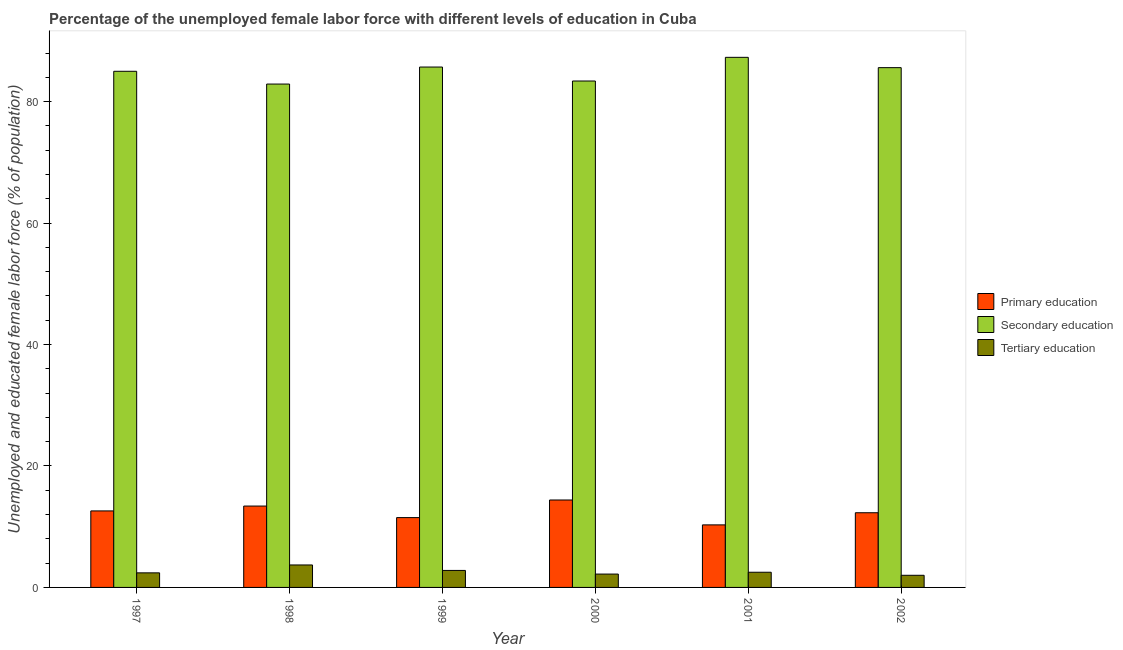How many different coloured bars are there?
Your answer should be very brief. 3. Are the number of bars per tick equal to the number of legend labels?
Offer a very short reply. Yes. Are the number of bars on each tick of the X-axis equal?
Your answer should be compact. Yes. What is the label of the 1st group of bars from the left?
Offer a terse response. 1997. What is the percentage of female labor force who received secondary education in 2002?
Make the answer very short. 85.6. Across all years, what is the maximum percentage of female labor force who received secondary education?
Provide a short and direct response. 87.3. Across all years, what is the minimum percentage of female labor force who received secondary education?
Provide a succinct answer. 82.9. What is the total percentage of female labor force who received secondary education in the graph?
Offer a very short reply. 509.9. What is the difference between the percentage of female labor force who received secondary education in 2000 and that in 2001?
Make the answer very short. -3.9. What is the difference between the percentage of female labor force who received primary education in 1999 and the percentage of female labor force who received tertiary education in 2000?
Provide a short and direct response. -2.9. What is the average percentage of female labor force who received tertiary education per year?
Keep it short and to the point. 2.6. What is the ratio of the percentage of female labor force who received secondary education in 1997 to that in 1999?
Offer a terse response. 0.99. Is the percentage of female labor force who received secondary education in 1999 less than that in 2000?
Make the answer very short. No. What is the difference between the highest and the second highest percentage of female labor force who received tertiary education?
Your answer should be compact. 0.9. What is the difference between the highest and the lowest percentage of female labor force who received tertiary education?
Your response must be concise. 1.7. In how many years, is the percentage of female labor force who received tertiary education greater than the average percentage of female labor force who received tertiary education taken over all years?
Offer a very short reply. 2. Is the sum of the percentage of female labor force who received tertiary education in 1999 and 2002 greater than the maximum percentage of female labor force who received primary education across all years?
Provide a short and direct response. Yes. What does the 3rd bar from the right in 2000 represents?
Provide a short and direct response. Primary education. What is the difference between two consecutive major ticks on the Y-axis?
Make the answer very short. 20. Are the values on the major ticks of Y-axis written in scientific E-notation?
Your answer should be compact. No. Does the graph contain any zero values?
Keep it short and to the point. No. Does the graph contain grids?
Keep it short and to the point. No. Where does the legend appear in the graph?
Ensure brevity in your answer.  Center right. How are the legend labels stacked?
Your answer should be compact. Vertical. What is the title of the graph?
Your response must be concise. Percentage of the unemployed female labor force with different levels of education in Cuba. What is the label or title of the X-axis?
Offer a terse response. Year. What is the label or title of the Y-axis?
Make the answer very short. Unemployed and educated female labor force (% of population). What is the Unemployed and educated female labor force (% of population) in Primary education in 1997?
Give a very brief answer. 12.6. What is the Unemployed and educated female labor force (% of population) of Tertiary education in 1997?
Provide a succinct answer. 2.4. What is the Unemployed and educated female labor force (% of population) in Primary education in 1998?
Your answer should be compact. 13.4. What is the Unemployed and educated female labor force (% of population) of Secondary education in 1998?
Offer a terse response. 82.9. What is the Unemployed and educated female labor force (% of population) in Tertiary education in 1998?
Offer a terse response. 3.7. What is the Unemployed and educated female labor force (% of population) of Primary education in 1999?
Provide a short and direct response. 11.5. What is the Unemployed and educated female labor force (% of population) in Secondary education in 1999?
Ensure brevity in your answer.  85.7. What is the Unemployed and educated female labor force (% of population) of Tertiary education in 1999?
Offer a terse response. 2.8. What is the Unemployed and educated female labor force (% of population) of Primary education in 2000?
Keep it short and to the point. 14.4. What is the Unemployed and educated female labor force (% of population) in Secondary education in 2000?
Offer a very short reply. 83.4. What is the Unemployed and educated female labor force (% of population) of Tertiary education in 2000?
Offer a terse response. 2.2. What is the Unemployed and educated female labor force (% of population) in Primary education in 2001?
Give a very brief answer. 10.3. What is the Unemployed and educated female labor force (% of population) of Secondary education in 2001?
Provide a succinct answer. 87.3. What is the Unemployed and educated female labor force (% of population) of Tertiary education in 2001?
Your answer should be compact. 2.5. What is the Unemployed and educated female labor force (% of population) of Primary education in 2002?
Your response must be concise. 12.3. What is the Unemployed and educated female labor force (% of population) in Secondary education in 2002?
Give a very brief answer. 85.6. Across all years, what is the maximum Unemployed and educated female labor force (% of population) of Primary education?
Offer a terse response. 14.4. Across all years, what is the maximum Unemployed and educated female labor force (% of population) in Secondary education?
Offer a terse response. 87.3. Across all years, what is the maximum Unemployed and educated female labor force (% of population) in Tertiary education?
Your answer should be compact. 3.7. Across all years, what is the minimum Unemployed and educated female labor force (% of population) in Primary education?
Your response must be concise. 10.3. Across all years, what is the minimum Unemployed and educated female labor force (% of population) in Secondary education?
Provide a succinct answer. 82.9. What is the total Unemployed and educated female labor force (% of population) in Primary education in the graph?
Your answer should be compact. 74.5. What is the total Unemployed and educated female labor force (% of population) of Secondary education in the graph?
Provide a short and direct response. 509.9. What is the difference between the Unemployed and educated female labor force (% of population) of Primary education in 1997 and that in 2000?
Ensure brevity in your answer.  -1.8. What is the difference between the Unemployed and educated female labor force (% of population) of Tertiary education in 1997 and that in 2002?
Ensure brevity in your answer.  0.4. What is the difference between the Unemployed and educated female labor force (% of population) of Primary education in 1998 and that in 1999?
Offer a terse response. 1.9. What is the difference between the Unemployed and educated female labor force (% of population) of Secondary education in 1998 and that in 1999?
Your answer should be compact. -2.8. What is the difference between the Unemployed and educated female labor force (% of population) in Tertiary education in 1998 and that in 1999?
Give a very brief answer. 0.9. What is the difference between the Unemployed and educated female labor force (% of population) in Secondary education in 1998 and that in 2000?
Provide a succinct answer. -0.5. What is the difference between the Unemployed and educated female labor force (% of population) in Tertiary education in 1998 and that in 2000?
Your answer should be compact. 1.5. What is the difference between the Unemployed and educated female labor force (% of population) of Secondary education in 1998 and that in 2001?
Your answer should be compact. -4.4. What is the difference between the Unemployed and educated female labor force (% of population) in Tertiary education in 1998 and that in 2001?
Ensure brevity in your answer.  1.2. What is the difference between the Unemployed and educated female labor force (% of population) of Primary education in 1998 and that in 2002?
Your answer should be very brief. 1.1. What is the difference between the Unemployed and educated female labor force (% of population) of Secondary education in 1998 and that in 2002?
Make the answer very short. -2.7. What is the difference between the Unemployed and educated female labor force (% of population) of Primary education in 1999 and that in 2000?
Your answer should be very brief. -2.9. What is the difference between the Unemployed and educated female labor force (% of population) of Tertiary education in 1999 and that in 2000?
Provide a short and direct response. 0.6. What is the difference between the Unemployed and educated female labor force (% of population) in Primary education in 1999 and that in 2001?
Keep it short and to the point. 1.2. What is the difference between the Unemployed and educated female labor force (% of population) of Secondary education in 1999 and that in 2001?
Your answer should be very brief. -1.6. What is the difference between the Unemployed and educated female labor force (% of population) of Tertiary education in 1999 and that in 2001?
Your response must be concise. 0.3. What is the difference between the Unemployed and educated female labor force (% of population) of Primary education in 2000 and that in 2001?
Make the answer very short. 4.1. What is the difference between the Unemployed and educated female labor force (% of population) in Primary education in 2000 and that in 2002?
Offer a terse response. 2.1. What is the difference between the Unemployed and educated female labor force (% of population) in Secondary education in 2000 and that in 2002?
Provide a short and direct response. -2.2. What is the difference between the Unemployed and educated female labor force (% of population) of Secondary education in 2001 and that in 2002?
Your answer should be very brief. 1.7. What is the difference between the Unemployed and educated female labor force (% of population) in Primary education in 1997 and the Unemployed and educated female labor force (% of population) in Secondary education in 1998?
Ensure brevity in your answer.  -70.3. What is the difference between the Unemployed and educated female labor force (% of population) in Secondary education in 1997 and the Unemployed and educated female labor force (% of population) in Tertiary education in 1998?
Offer a very short reply. 81.3. What is the difference between the Unemployed and educated female labor force (% of population) in Primary education in 1997 and the Unemployed and educated female labor force (% of population) in Secondary education in 1999?
Provide a succinct answer. -73.1. What is the difference between the Unemployed and educated female labor force (% of population) in Primary education in 1997 and the Unemployed and educated female labor force (% of population) in Tertiary education in 1999?
Keep it short and to the point. 9.8. What is the difference between the Unemployed and educated female labor force (% of population) of Secondary education in 1997 and the Unemployed and educated female labor force (% of population) of Tertiary education in 1999?
Make the answer very short. 82.2. What is the difference between the Unemployed and educated female labor force (% of population) of Primary education in 1997 and the Unemployed and educated female labor force (% of population) of Secondary education in 2000?
Keep it short and to the point. -70.8. What is the difference between the Unemployed and educated female labor force (% of population) in Primary education in 1997 and the Unemployed and educated female labor force (% of population) in Tertiary education in 2000?
Offer a very short reply. 10.4. What is the difference between the Unemployed and educated female labor force (% of population) of Secondary education in 1997 and the Unemployed and educated female labor force (% of population) of Tertiary education in 2000?
Keep it short and to the point. 82.8. What is the difference between the Unemployed and educated female labor force (% of population) of Primary education in 1997 and the Unemployed and educated female labor force (% of population) of Secondary education in 2001?
Your answer should be very brief. -74.7. What is the difference between the Unemployed and educated female labor force (% of population) in Secondary education in 1997 and the Unemployed and educated female labor force (% of population) in Tertiary education in 2001?
Ensure brevity in your answer.  82.5. What is the difference between the Unemployed and educated female labor force (% of population) of Primary education in 1997 and the Unemployed and educated female labor force (% of population) of Secondary education in 2002?
Your answer should be very brief. -73. What is the difference between the Unemployed and educated female labor force (% of population) of Secondary education in 1997 and the Unemployed and educated female labor force (% of population) of Tertiary education in 2002?
Provide a succinct answer. 83. What is the difference between the Unemployed and educated female labor force (% of population) in Primary education in 1998 and the Unemployed and educated female labor force (% of population) in Secondary education in 1999?
Give a very brief answer. -72.3. What is the difference between the Unemployed and educated female labor force (% of population) in Primary education in 1998 and the Unemployed and educated female labor force (% of population) in Tertiary education in 1999?
Make the answer very short. 10.6. What is the difference between the Unemployed and educated female labor force (% of population) in Secondary education in 1998 and the Unemployed and educated female labor force (% of population) in Tertiary education in 1999?
Offer a terse response. 80.1. What is the difference between the Unemployed and educated female labor force (% of population) in Primary education in 1998 and the Unemployed and educated female labor force (% of population) in Secondary education in 2000?
Keep it short and to the point. -70. What is the difference between the Unemployed and educated female labor force (% of population) in Secondary education in 1998 and the Unemployed and educated female labor force (% of population) in Tertiary education in 2000?
Give a very brief answer. 80.7. What is the difference between the Unemployed and educated female labor force (% of population) in Primary education in 1998 and the Unemployed and educated female labor force (% of population) in Secondary education in 2001?
Provide a succinct answer. -73.9. What is the difference between the Unemployed and educated female labor force (% of population) in Primary education in 1998 and the Unemployed and educated female labor force (% of population) in Tertiary education in 2001?
Your response must be concise. 10.9. What is the difference between the Unemployed and educated female labor force (% of population) of Secondary education in 1998 and the Unemployed and educated female labor force (% of population) of Tertiary education in 2001?
Give a very brief answer. 80.4. What is the difference between the Unemployed and educated female labor force (% of population) of Primary education in 1998 and the Unemployed and educated female labor force (% of population) of Secondary education in 2002?
Make the answer very short. -72.2. What is the difference between the Unemployed and educated female labor force (% of population) of Secondary education in 1998 and the Unemployed and educated female labor force (% of population) of Tertiary education in 2002?
Your answer should be compact. 80.9. What is the difference between the Unemployed and educated female labor force (% of population) of Primary education in 1999 and the Unemployed and educated female labor force (% of population) of Secondary education in 2000?
Provide a succinct answer. -71.9. What is the difference between the Unemployed and educated female labor force (% of population) in Secondary education in 1999 and the Unemployed and educated female labor force (% of population) in Tertiary education in 2000?
Ensure brevity in your answer.  83.5. What is the difference between the Unemployed and educated female labor force (% of population) of Primary education in 1999 and the Unemployed and educated female labor force (% of population) of Secondary education in 2001?
Make the answer very short. -75.8. What is the difference between the Unemployed and educated female labor force (% of population) in Secondary education in 1999 and the Unemployed and educated female labor force (% of population) in Tertiary education in 2001?
Provide a short and direct response. 83.2. What is the difference between the Unemployed and educated female labor force (% of population) in Primary education in 1999 and the Unemployed and educated female labor force (% of population) in Secondary education in 2002?
Give a very brief answer. -74.1. What is the difference between the Unemployed and educated female labor force (% of population) in Secondary education in 1999 and the Unemployed and educated female labor force (% of population) in Tertiary education in 2002?
Offer a terse response. 83.7. What is the difference between the Unemployed and educated female labor force (% of population) in Primary education in 2000 and the Unemployed and educated female labor force (% of population) in Secondary education in 2001?
Give a very brief answer. -72.9. What is the difference between the Unemployed and educated female labor force (% of population) of Primary education in 2000 and the Unemployed and educated female labor force (% of population) of Tertiary education in 2001?
Offer a terse response. 11.9. What is the difference between the Unemployed and educated female labor force (% of population) of Secondary education in 2000 and the Unemployed and educated female labor force (% of population) of Tertiary education in 2001?
Keep it short and to the point. 80.9. What is the difference between the Unemployed and educated female labor force (% of population) in Primary education in 2000 and the Unemployed and educated female labor force (% of population) in Secondary education in 2002?
Offer a very short reply. -71.2. What is the difference between the Unemployed and educated female labor force (% of population) of Secondary education in 2000 and the Unemployed and educated female labor force (% of population) of Tertiary education in 2002?
Your answer should be compact. 81.4. What is the difference between the Unemployed and educated female labor force (% of population) in Primary education in 2001 and the Unemployed and educated female labor force (% of population) in Secondary education in 2002?
Provide a succinct answer. -75.3. What is the difference between the Unemployed and educated female labor force (% of population) in Secondary education in 2001 and the Unemployed and educated female labor force (% of population) in Tertiary education in 2002?
Provide a succinct answer. 85.3. What is the average Unemployed and educated female labor force (% of population) of Primary education per year?
Provide a short and direct response. 12.42. What is the average Unemployed and educated female labor force (% of population) in Secondary education per year?
Offer a very short reply. 84.98. What is the average Unemployed and educated female labor force (% of population) in Tertiary education per year?
Provide a short and direct response. 2.6. In the year 1997, what is the difference between the Unemployed and educated female labor force (% of population) of Primary education and Unemployed and educated female labor force (% of population) of Secondary education?
Your answer should be very brief. -72.4. In the year 1997, what is the difference between the Unemployed and educated female labor force (% of population) in Secondary education and Unemployed and educated female labor force (% of population) in Tertiary education?
Provide a short and direct response. 82.6. In the year 1998, what is the difference between the Unemployed and educated female labor force (% of population) of Primary education and Unemployed and educated female labor force (% of population) of Secondary education?
Your answer should be very brief. -69.5. In the year 1998, what is the difference between the Unemployed and educated female labor force (% of population) in Secondary education and Unemployed and educated female labor force (% of population) in Tertiary education?
Provide a short and direct response. 79.2. In the year 1999, what is the difference between the Unemployed and educated female labor force (% of population) of Primary education and Unemployed and educated female labor force (% of population) of Secondary education?
Keep it short and to the point. -74.2. In the year 1999, what is the difference between the Unemployed and educated female labor force (% of population) in Secondary education and Unemployed and educated female labor force (% of population) in Tertiary education?
Make the answer very short. 82.9. In the year 2000, what is the difference between the Unemployed and educated female labor force (% of population) in Primary education and Unemployed and educated female labor force (% of population) in Secondary education?
Provide a short and direct response. -69. In the year 2000, what is the difference between the Unemployed and educated female labor force (% of population) of Primary education and Unemployed and educated female labor force (% of population) of Tertiary education?
Provide a succinct answer. 12.2. In the year 2000, what is the difference between the Unemployed and educated female labor force (% of population) in Secondary education and Unemployed and educated female labor force (% of population) in Tertiary education?
Your response must be concise. 81.2. In the year 2001, what is the difference between the Unemployed and educated female labor force (% of population) of Primary education and Unemployed and educated female labor force (% of population) of Secondary education?
Give a very brief answer. -77. In the year 2001, what is the difference between the Unemployed and educated female labor force (% of population) in Secondary education and Unemployed and educated female labor force (% of population) in Tertiary education?
Ensure brevity in your answer.  84.8. In the year 2002, what is the difference between the Unemployed and educated female labor force (% of population) of Primary education and Unemployed and educated female labor force (% of population) of Secondary education?
Ensure brevity in your answer.  -73.3. In the year 2002, what is the difference between the Unemployed and educated female labor force (% of population) of Primary education and Unemployed and educated female labor force (% of population) of Tertiary education?
Your answer should be very brief. 10.3. In the year 2002, what is the difference between the Unemployed and educated female labor force (% of population) in Secondary education and Unemployed and educated female labor force (% of population) in Tertiary education?
Give a very brief answer. 83.6. What is the ratio of the Unemployed and educated female labor force (% of population) of Primary education in 1997 to that in 1998?
Give a very brief answer. 0.94. What is the ratio of the Unemployed and educated female labor force (% of population) in Secondary education in 1997 to that in 1998?
Your answer should be very brief. 1.03. What is the ratio of the Unemployed and educated female labor force (% of population) in Tertiary education in 1997 to that in 1998?
Your response must be concise. 0.65. What is the ratio of the Unemployed and educated female labor force (% of population) in Primary education in 1997 to that in 1999?
Make the answer very short. 1.1. What is the ratio of the Unemployed and educated female labor force (% of population) of Secondary education in 1997 to that in 1999?
Provide a short and direct response. 0.99. What is the ratio of the Unemployed and educated female labor force (% of population) of Tertiary education in 1997 to that in 1999?
Make the answer very short. 0.86. What is the ratio of the Unemployed and educated female labor force (% of population) of Secondary education in 1997 to that in 2000?
Provide a succinct answer. 1.02. What is the ratio of the Unemployed and educated female labor force (% of population) in Primary education in 1997 to that in 2001?
Offer a very short reply. 1.22. What is the ratio of the Unemployed and educated female labor force (% of population) of Secondary education in 1997 to that in 2001?
Provide a short and direct response. 0.97. What is the ratio of the Unemployed and educated female labor force (% of population) of Tertiary education in 1997 to that in 2001?
Your answer should be compact. 0.96. What is the ratio of the Unemployed and educated female labor force (% of population) in Primary education in 1997 to that in 2002?
Offer a terse response. 1.02. What is the ratio of the Unemployed and educated female labor force (% of population) of Tertiary education in 1997 to that in 2002?
Ensure brevity in your answer.  1.2. What is the ratio of the Unemployed and educated female labor force (% of population) of Primary education in 1998 to that in 1999?
Your response must be concise. 1.17. What is the ratio of the Unemployed and educated female labor force (% of population) of Secondary education in 1998 to that in 1999?
Keep it short and to the point. 0.97. What is the ratio of the Unemployed and educated female labor force (% of population) of Tertiary education in 1998 to that in 1999?
Provide a succinct answer. 1.32. What is the ratio of the Unemployed and educated female labor force (% of population) in Primary education in 1998 to that in 2000?
Ensure brevity in your answer.  0.93. What is the ratio of the Unemployed and educated female labor force (% of population) of Secondary education in 1998 to that in 2000?
Your answer should be very brief. 0.99. What is the ratio of the Unemployed and educated female labor force (% of population) in Tertiary education in 1998 to that in 2000?
Provide a short and direct response. 1.68. What is the ratio of the Unemployed and educated female labor force (% of population) in Primary education in 1998 to that in 2001?
Provide a short and direct response. 1.3. What is the ratio of the Unemployed and educated female labor force (% of population) in Secondary education in 1998 to that in 2001?
Make the answer very short. 0.95. What is the ratio of the Unemployed and educated female labor force (% of population) in Tertiary education in 1998 to that in 2001?
Make the answer very short. 1.48. What is the ratio of the Unemployed and educated female labor force (% of population) of Primary education in 1998 to that in 2002?
Your answer should be very brief. 1.09. What is the ratio of the Unemployed and educated female labor force (% of population) of Secondary education in 1998 to that in 2002?
Your response must be concise. 0.97. What is the ratio of the Unemployed and educated female labor force (% of population) in Tertiary education in 1998 to that in 2002?
Ensure brevity in your answer.  1.85. What is the ratio of the Unemployed and educated female labor force (% of population) of Primary education in 1999 to that in 2000?
Ensure brevity in your answer.  0.8. What is the ratio of the Unemployed and educated female labor force (% of population) of Secondary education in 1999 to that in 2000?
Provide a succinct answer. 1.03. What is the ratio of the Unemployed and educated female labor force (% of population) of Tertiary education in 1999 to that in 2000?
Your answer should be very brief. 1.27. What is the ratio of the Unemployed and educated female labor force (% of population) in Primary education in 1999 to that in 2001?
Offer a very short reply. 1.12. What is the ratio of the Unemployed and educated female labor force (% of population) in Secondary education in 1999 to that in 2001?
Your answer should be compact. 0.98. What is the ratio of the Unemployed and educated female labor force (% of population) in Tertiary education in 1999 to that in 2001?
Offer a very short reply. 1.12. What is the ratio of the Unemployed and educated female labor force (% of population) in Primary education in 1999 to that in 2002?
Keep it short and to the point. 0.94. What is the ratio of the Unemployed and educated female labor force (% of population) in Primary education in 2000 to that in 2001?
Make the answer very short. 1.4. What is the ratio of the Unemployed and educated female labor force (% of population) of Secondary education in 2000 to that in 2001?
Give a very brief answer. 0.96. What is the ratio of the Unemployed and educated female labor force (% of population) of Tertiary education in 2000 to that in 2001?
Give a very brief answer. 0.88. What is the ratio of the Unemployed and educated female labor force (% of population) in Primary education in 2000 to that in 2002?
Offer a terse response. 1.17. What is the ratio of the Unemployed and educated female labor force (% of population) of Secondary education in 2000 to that in 2002?
Provide a short and direct response. 0.97. What is the ratio of the Unemployed and educated female labor force (% of population) in Tertiary education in 2000 to that in 2002?
Provide a succinct answer. 1.1. What is the ratio of the Unemployed and educated female labor force (% of population) in Primary education in 2001 to that in 2002?
Give a very brief answer. 0.84. What is the ratio of the Unemployed and educated female labor force (% of population) of Secondary education in 2001 to that in 2002?
Your answer should be compact. 1.02. What is the ratio of the Unemployed and educated female labor force (% of population) in Tertiary education in 2001 to that in 2002?
Keep it short and to the point. 1.25. What is the difference between the highest and the second highest Unemployed and educated female labor force (% of population) in Primary education?
Provide a short and direct response. 1. What is the difference between the highest and the second highest Unemployed and educated female labor force (% of population) in Secondary education?
Offer a terse response. 1.6. What is the difference between the highest and the lowest Unemployed and educated female labor force (% of population) in Primary education?
Your response must be concise. 4.1. 